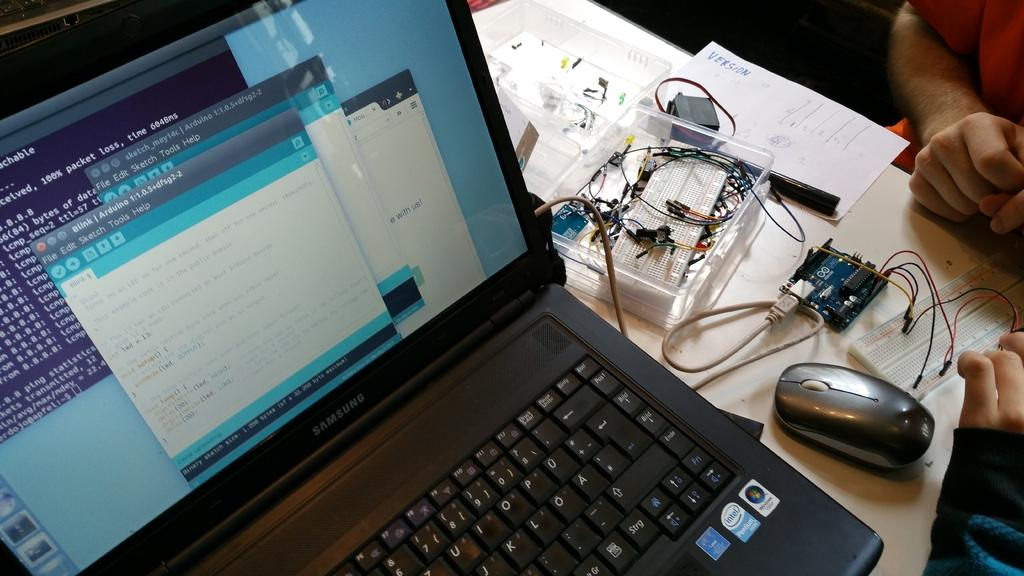<image>
Write a terse but informative summary of the picture. a Samsung lap top computer open to a monitor with several windows 